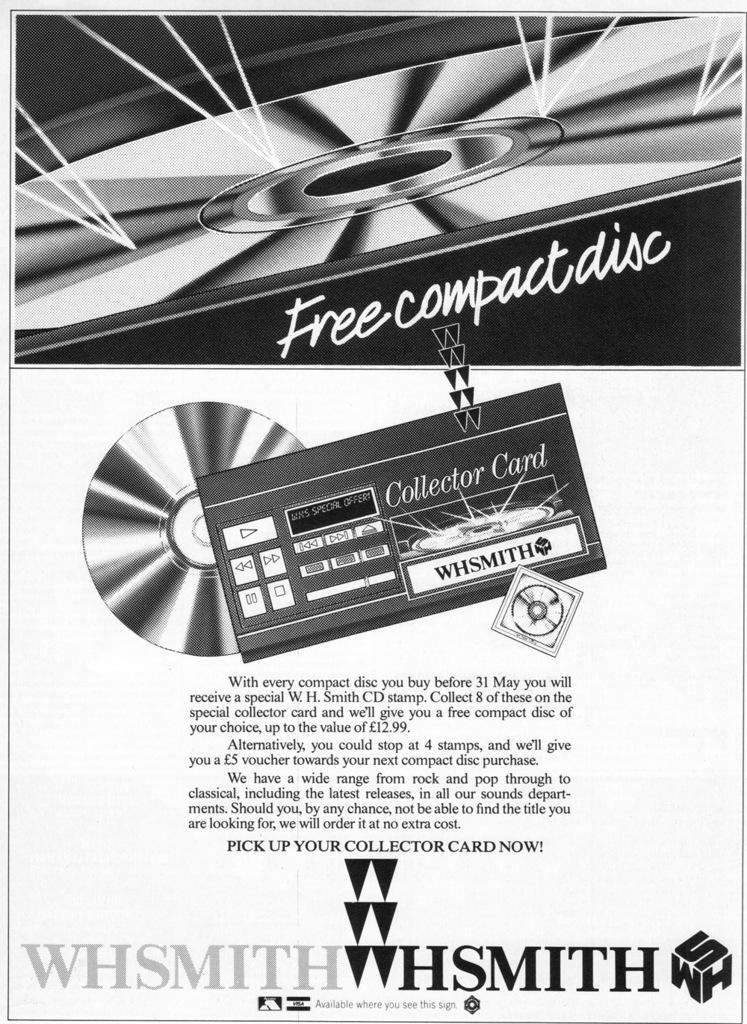What type of visual is the image? The image is a poster. What items can be seen in the poster? There are compact discs and a card in the poster. What else is present in the poster besides the items? There is text in the poster. How many chairs are depicted in the poster? There are no chairs visible in the poster. What type of relationship does the father have with the items in the poster? There is no father present in the poster, and therefore no relationship can be established. 